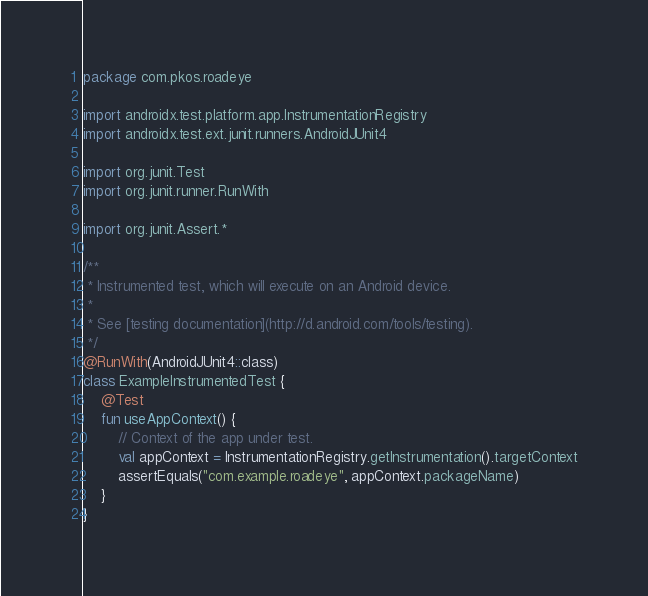<code> <loc_0><loc_0><loc_500><loc_500><_Kotlin_>package com.pkos.roadeye

import androidx.test.platform.app.InstrumentationRegistry
import androidx.test.ext.junit.runners.AndroidJUnit4

import org.junit.Test
import org.junit.runner.RunWith

import org.junit.Assert.*

/**
 * Instrumented test, which will execute on an Android device.
 *
 * See [testing documentation](http://d.android.com/tools/testing).
 */
@RunWith(AndroidJUnit4::class)
class ExampleInstrumentedTest {
    @Test
    fun useAppContext() {
        // Context of the app under test.
        val appContext = InstrumentationRegistry.getInstrumentation().targetContext
        assertEquals("com.example.roadeye", appContext.packageName)
    }
}
</code> 